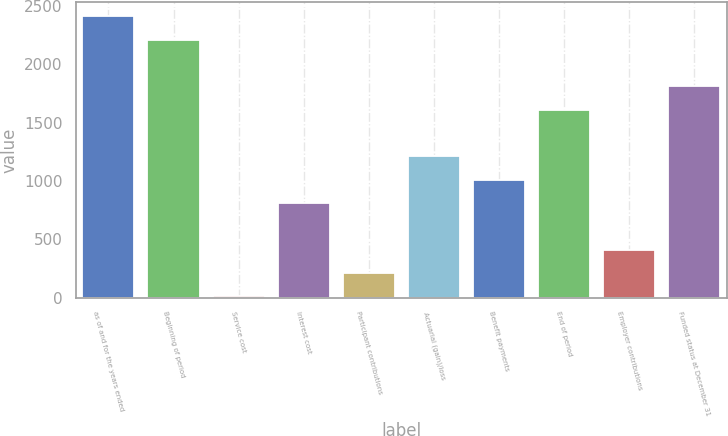Convert chart to OTSL. <chart><loc_0><loc_0><loc_500><loc_500><bar_chart><fcel>as of and for the years ended<fcel>Beginning of period<fcel>Service cost<fcel>Interest cost<fcel>Participant contributions<fcel>Actuarial (gain)/loss<fcel>Benefit payments<fcel>End of period<fcel>Employer contributions<fcel>Funded status at December 31<nl><fcel>2413.6<fcel>2213.3<fcel>10<fcel>811.2<fcel>210.3<fcel>1211.8<fcel>1011.5<fcel>1612.4<fcel>410.6<fcel>1812.7<nl></chart> 